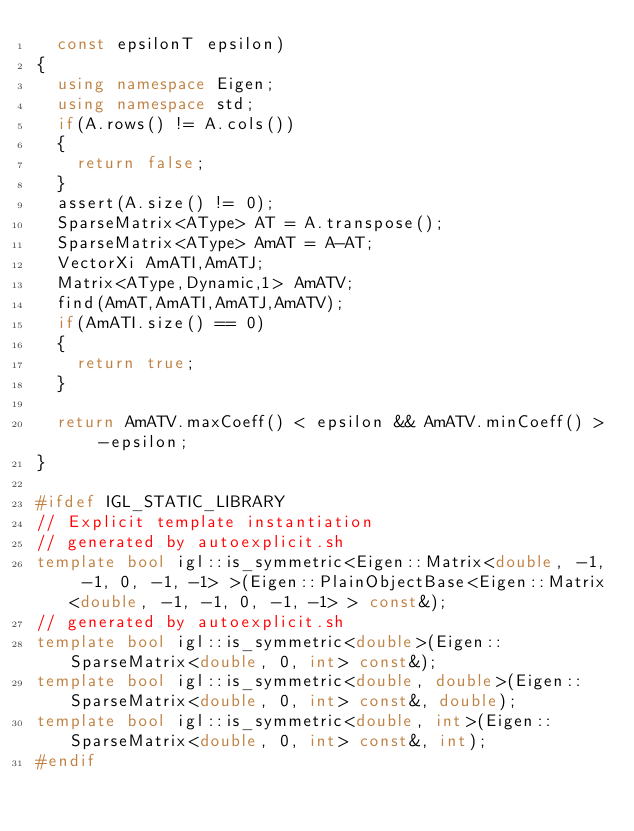Convert code to text. <code><loc_0><loc_0><loc_500><loc_500><_C++_>  const epsilonT epsilon)
{
  using namespace Eigen;
  using namespace std;
  if(A.rows() != A.cols())
  {
    return false;
  }
  assert(A.size() != 0);
  SparseMatrix<AType> AT = A.transpose();
  SparseMatrix<AType> AmAT = A-AT;
  VectorXi AmATI,AmATJ;
  Matrix<AType,Dynamic,1> AmATV;
  find(AmAT,AmATI,AmATJ,AmATV);
  if(AmATI.size() == 0)
  {
    return true;
  }
  
  return AmATV.maxCoeff() < epsilon && AmATV.minCoeff() > -epsilon;
}

#ifdef IGL_STATIC_LIBRARY
// Explicit template instantiation
// generated by autoexplicit.sh
template bool igl::is_symmetric<Eigen::Matrix<double, -1, -1, 0, -1, -1> >(Eigen::PlainObjectBase<Eigen::Matrix<double, -1, -1, 0, -1, -1> > const&);
// generated by autoexplicit.sh
template bool igl::is_symmetric<double>(Eigen::SparseMatrix<double, 0, int> const&);
template bool igl::is_symmetric<double, double>(Eigen::SparseMatrix<double, 0, int> const&, double);
template bool igl::is_symmetric<double, int>(Eigen::SparseMatrix<double, 0, int> const&, int);
#endif
</code> 